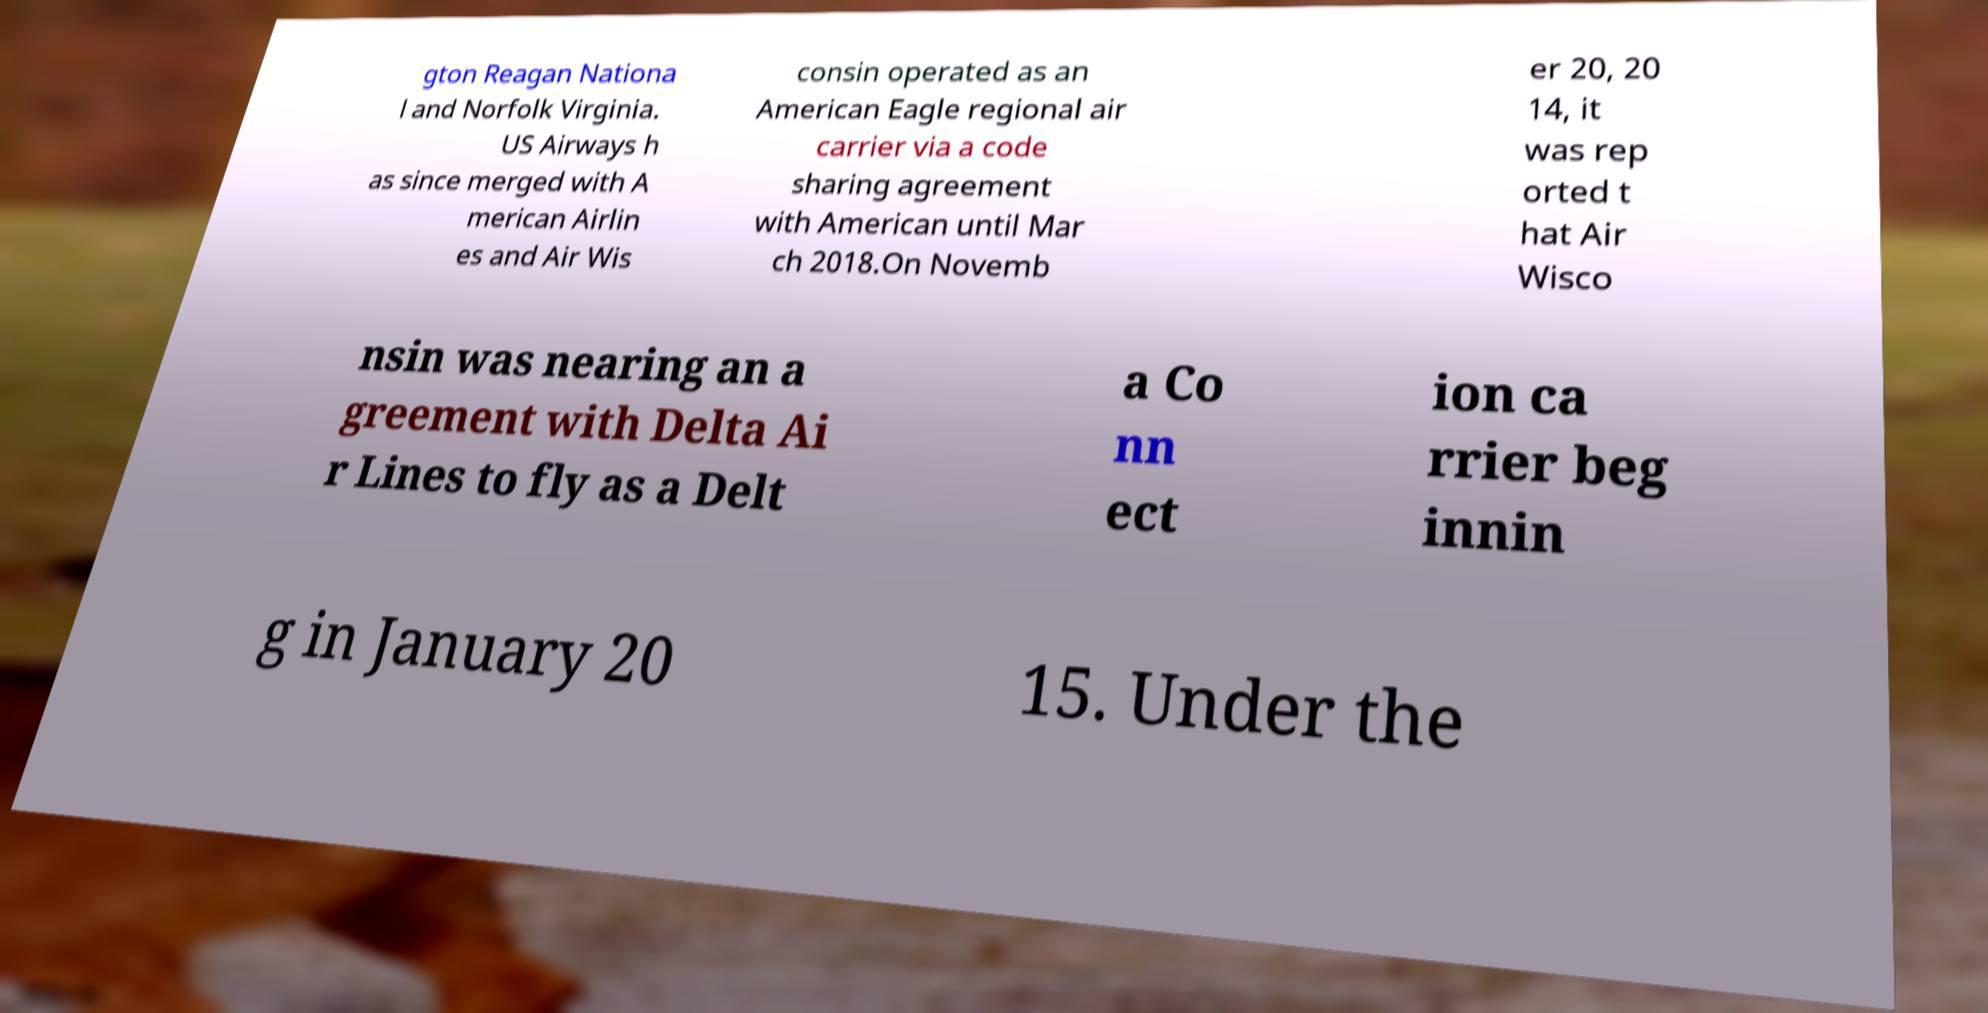Can you accurately transcribe the text from the provided image for me? gton Reagan Nationa l and Norfolk Virginia. US Airways h as since merged with A merican Airlin es and Air Wis consin operated as an American Eagle regional air carrier via a code sharing agreement with American until Mar ch 2018.On Novemb er 20, 20 14, it was rep orted t hat Air Wisco nsin was nearing an a greement with Delta Ai r Lines to fly as a Delt a Co nn ect ion ca rrier beg innin g in January 20 15. Under the 